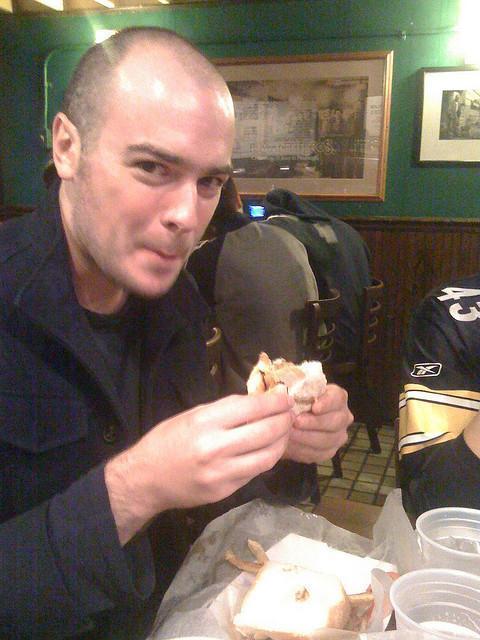How many people can be seen?
Give a very brief answer. 4. How many chairs are there?
Give a very brief answer. 2. How many sandwiches are there?
Give a very brief answer. 2. How many cups can be seen?
Give a very brief answer. 2. How many knives are shown in the picture?
Give a very brief answer. 0. 